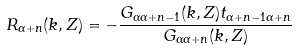Convert formula to latex. <formula><loc_0><loc_0><loc_500><loc_500>R _ { \alpha + n } ( { k } , Z ) = - \frac { G _ { \alpha \alpha + n - 1 } ( { k } , Z ) t _ { \alpha + n - 1 \alpha + n } } { G _ { \alpha \alpha + n } ( { k } , Z ) }</formula> 